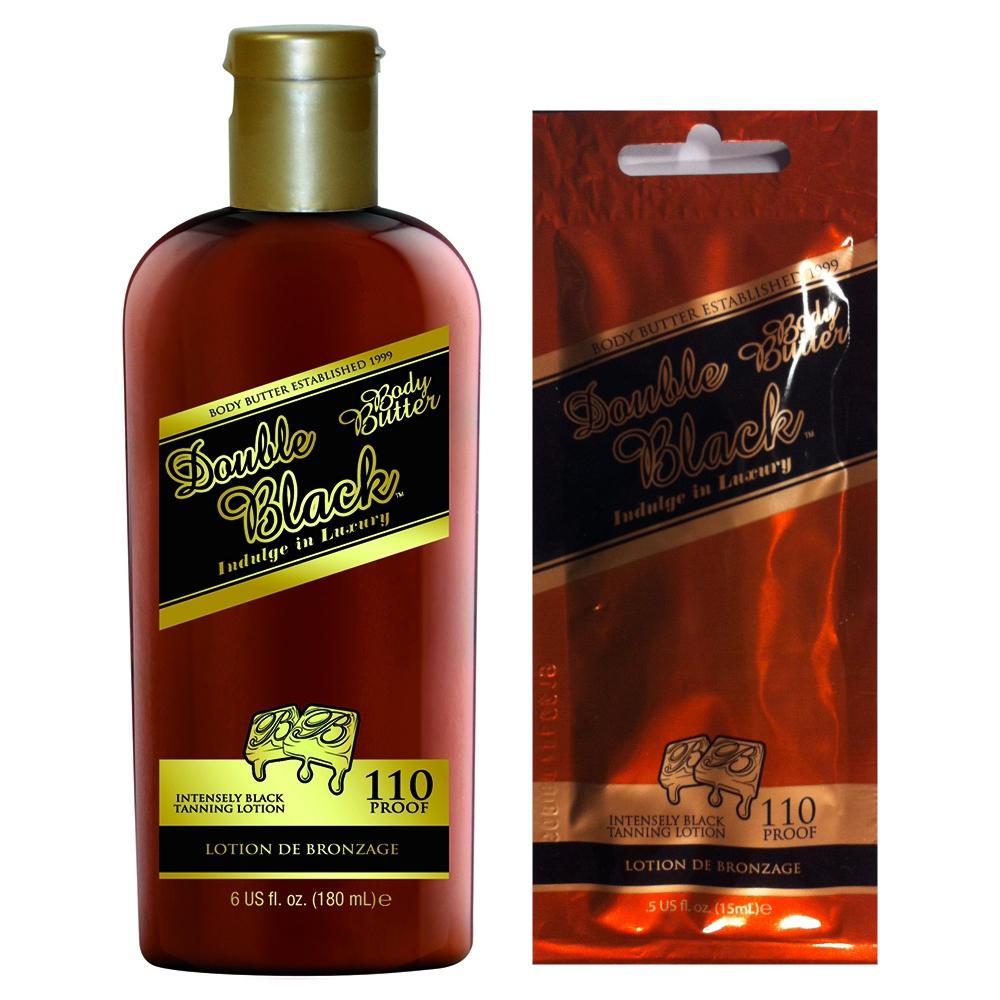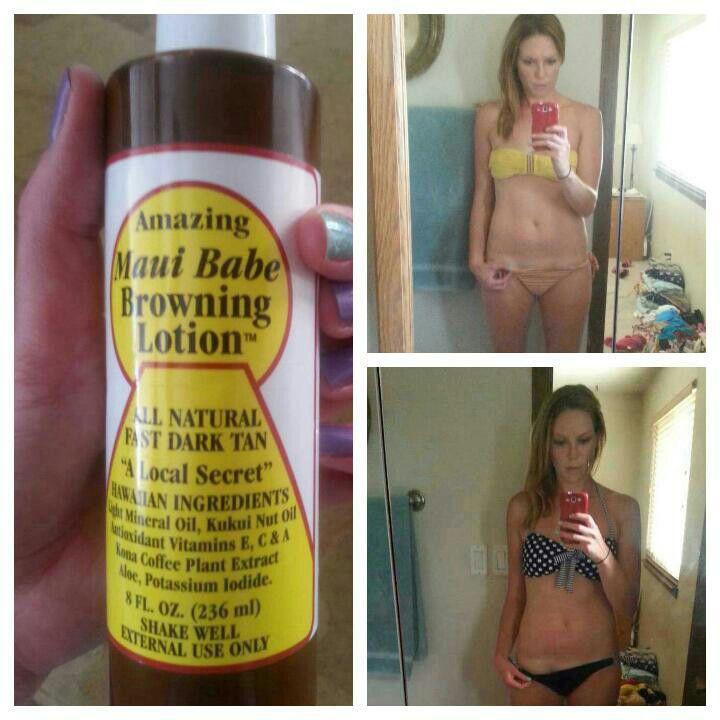The first image is the image on the left, the second image is the image on the right. For the images displayed, is the sentence "there is no more then three items" factually correct? Answer yes or no. No. 